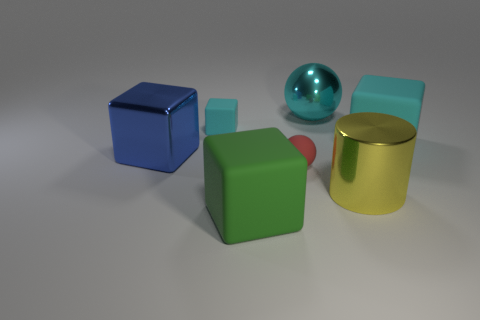What color is the big cylinder?
Give a very brief answer. Yellow. Does the cyan matte thing that is to the left of the large ball have the same shape as the tiny rubber object in front of the tiny block?
Provide a succinct answer. No. What color is the small object behind the blue thing?
Offer a terse response. Cyan. Is the number of yellow metal cylinders that are left of the yellow thing less than the number of cylinders behind the red object?
Ensure brevity in your answer.  No. How many other objects are the same material as the yellow cylinder?
Provide a short and direct response. 2. Do the small ball and the green block have the same material?
Give a very brief answer. Yes. How many other objects are the same size as the green object?
Your answer should be compact. 4. There is a cyan rubber cube to the right of the big cyan object that is on the left side of the large yellow thing; how big is it?
Provide a succinct answer. Large. The big rubber block behind the tiny matte object in front of the metallic thing to the left of the tiny red sphere is what color?
Ensure brevity in your answer.  Cyan. What size is the shiny object that is in front of the small cyan block and right of the small cube?
Give a very brief answer. Large. 